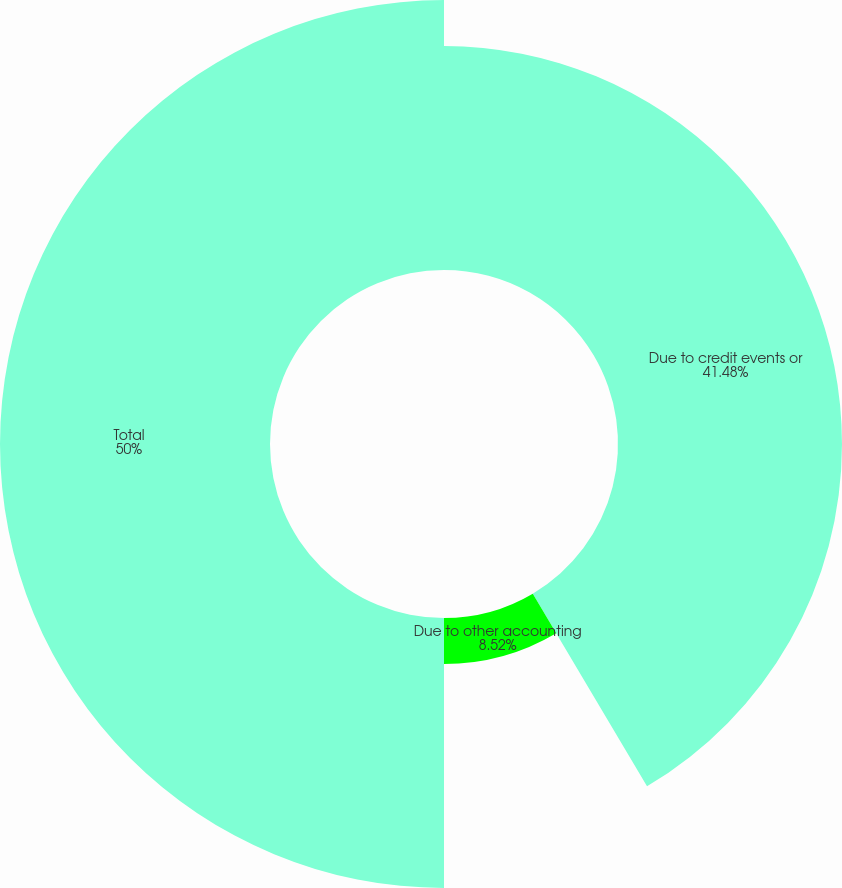Convert chart to OTSL. <chart><loc_0><loc_0><loc_500><loc_500><pie_chart><fcel>Due to credit events or<fcel>Due to other accounting<fcel>Total<nl><fcel>41.48%<fcel>8.52%<fcel>50.0%<nl></chart> 